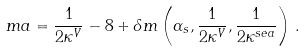Convert formula to latex. <formula><loc_0><loc_0><loc_500><loc_500>m a = \frac { 1 } { 2 \kappa ^ { V } } - 8 + \delta m \left ( \alpha _ { s } , \frac { 1 } { 2 \kappa ^ { V } } , \frac { 1 } { 2 \kappa ^ { s e a } } \right ) \, .</formula> 